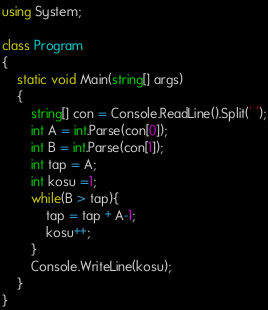Convert code to text. <code><loc_0><loc_0><loc_500><loc_500><_C#_>using System;

class Program
{
	static void Main(string[] args)
	{
		string[] con = Console.ReadLine().Split(' ');
		int A = int.Parse(con[0]);
		int B = int.Parse(con[1]);
		int tap = A;
		int kosu =1;
		while(B > tap){
			tap = tap + A-1;
			kosu++;
		}
		Console.WriteLine(kosu);
	}
}</code> 